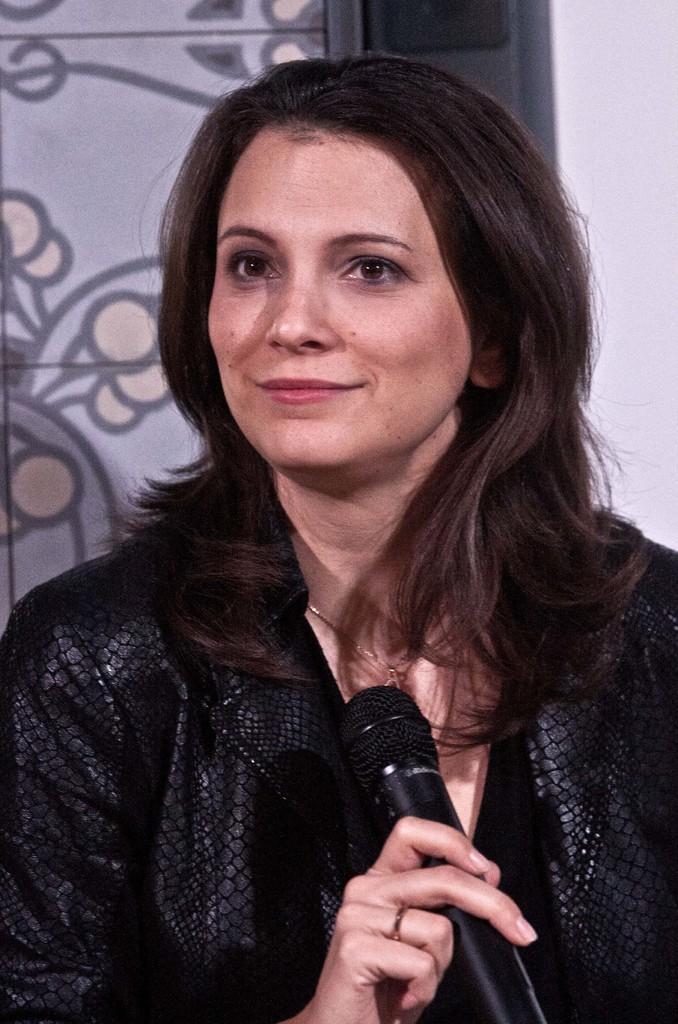How would you summarize this image in a sentence or two? Here is a woman wearing black dress and holding mike in her hand. At background I can see a design on the door. 